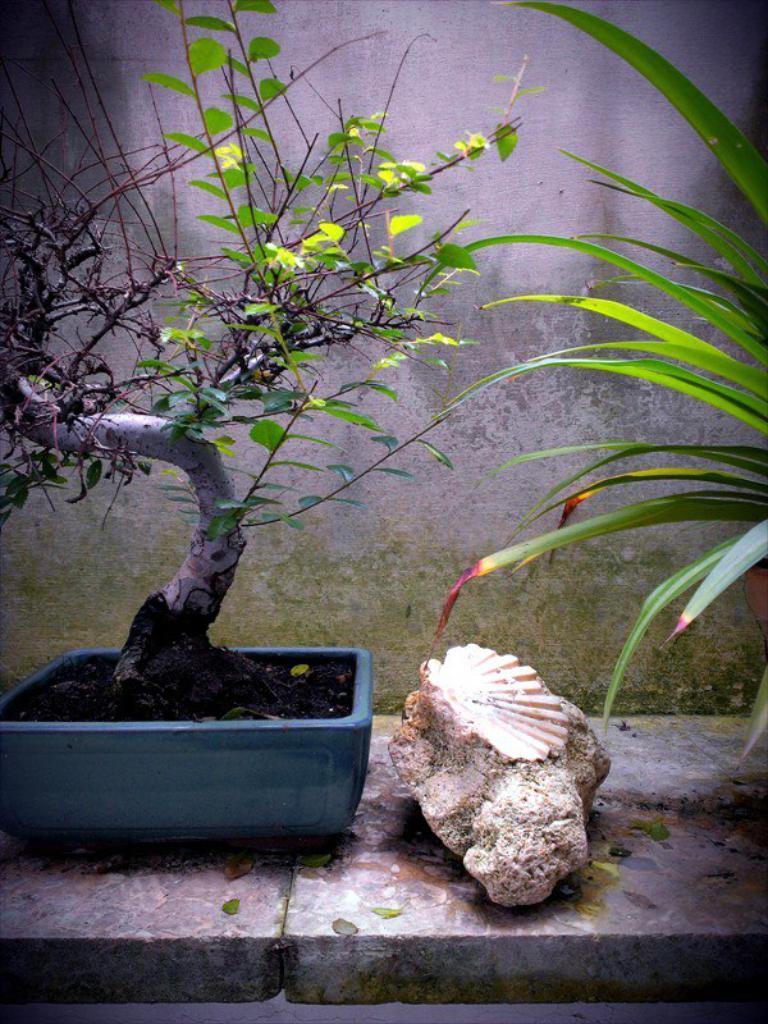Describe this image in one or two sentences. In this picture I can observe a plant in the plant pot. This plant pot is in blue color. Beside the plant pot there is a stone. In the background I can observe a wall. 